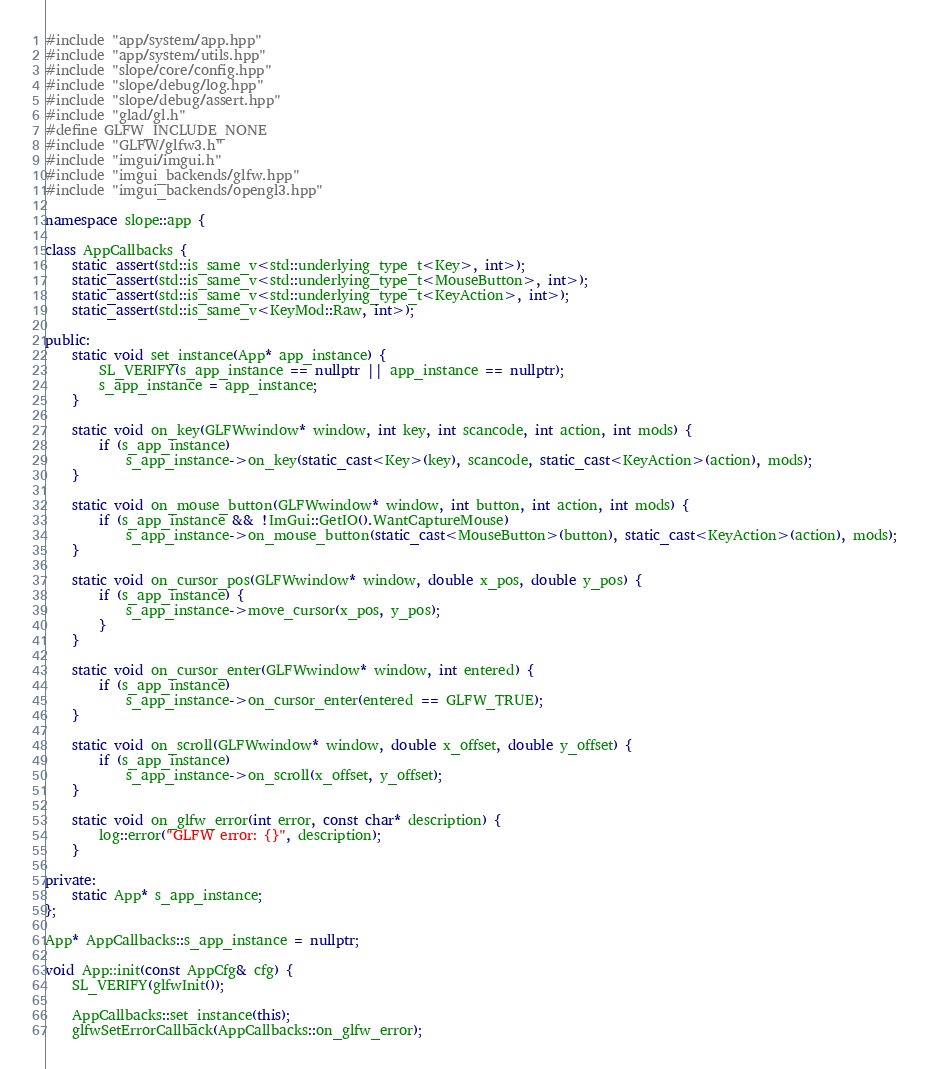Convert code to text. <code><loc_0><loc_0><loc_500><loc_500><_C++_>#include "app/system/app.hpp"
#include "app/system/utils.hpp"
#include "slope/core/config.hpp"
#include "slope/debug/log.hpp"
#include "slope/debug/assert.hpp"
#include "glad/gl.h"
#define GLFW_INCLUDE_NONE
#include "GLFW/glfw3.h"
#include "imgui/imgui.h"
#include "imgui_backends/glfw.hpp"
#include "imgui_backends/opengl3.hpp"

namespace slope::app {

class AppCallbacks {
    static_assert(std::is_same_v<std::underlying_type_t<Key>, int>);
    static_assert(std::is_same_v<std::underlying_type_t<MouseButton>, int>);
    static_assert(std::is_same_v<std::underlying_type_t<KeyAction>, int>);
    static_assert(std::is_same_v<KeyMod::Raw, int>);

public:
    static void set_instance(App* app_instance) {
        SL_VERIFY(s_app_instance == nullptr || app_instance == nullptr);
        s_app_instance = app_instance;
    }

    static void on_key(GLFWwindow* window, int key, int scancode, int action, int mods) {
        if (s_app_instance)
            s_app_instance->on_key(static_cast<Key>(key), scancode, static_cast<KeyAction>(action), mods);
    }

    static void on_mouse_button(GLFWwindow* window, int button, int action, int mods) {
        if (s_app_instance && !ImGui::GetIO().WantCaptureMouse)
            s_app_instance->on_mouse_button(static_cast<MouseButton>(button), static_cast<KeyAction>(action), mods);
    }

    static void on_cursor_pos(GLFWwindow* window, double x_pos, double y_pos) {
        if (s_app_instance) {
            s_app_instance->move_cursor(x_pos, y_pos);
        }
    }

    static void on_cursor_enter(GLFWwindow* window, int entered) {
        if (s_app_instance)
            s_app_instance->on_cursor_enter(entered == GLFW_TRUE);
    }

    static void on_scroll(GLFWwindow* window, double x_offset, double y_offset) {
        if (s_app_instance)
            s_app_instance->on_scroll(x_offset, y_offset);
    }

    static void on_glfw_error(int error, const char* description) {
        log::error("GLFW error: {}", description);
    }

private:
    static App* s_app_instance;
};

App* AppCallbacks::s_app_instance = nullptr;

void App::init(const AppCfg& cfg) {
    SL_VERIFY(glfwInit());

    AppCallbacks::set_instance(this);
    glfwSetErrorCallback(AppCallbacks::on_glfw_error);
</code> 